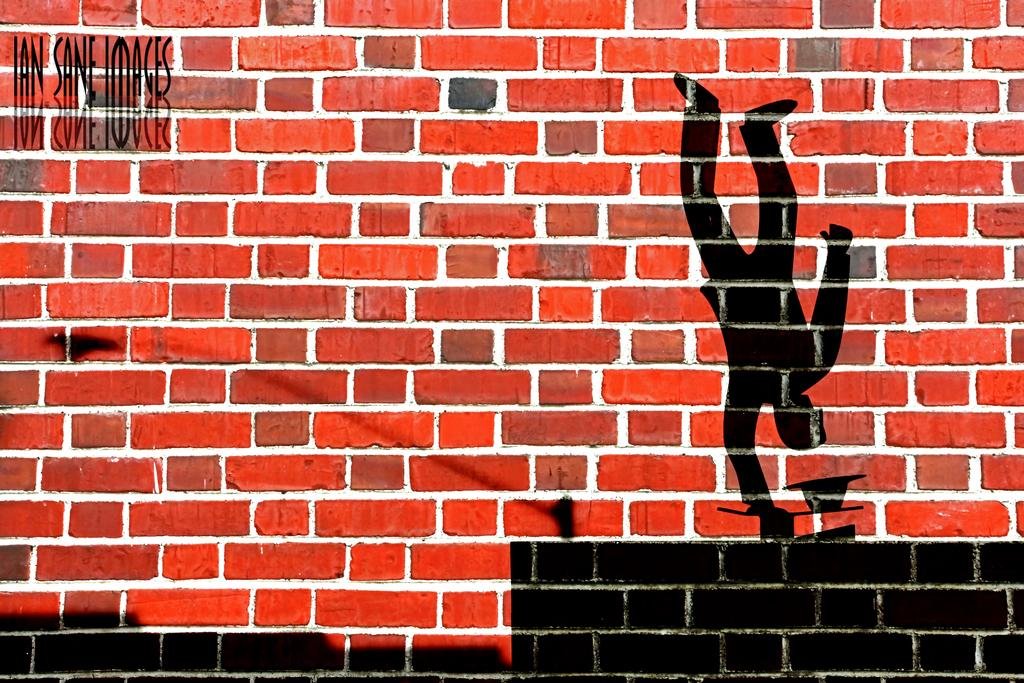What type of structure is visible in the image? There is a brick wall in the image. What can be seen on the right side of the image? There is a painting of a person doing a stunt on the right side of the image. Where is the quotation located in the image? There is a quotation in the top left corner of the image. What type of growth can be seen on the person doing a stunt in the image? There is no growth visible on the person doing a stunt in the image, as it is a painting. Is there a collar visible on the person doing a stunt in the image? There is no collar visible on the person doing a stunt in the image, as it is a painting. 